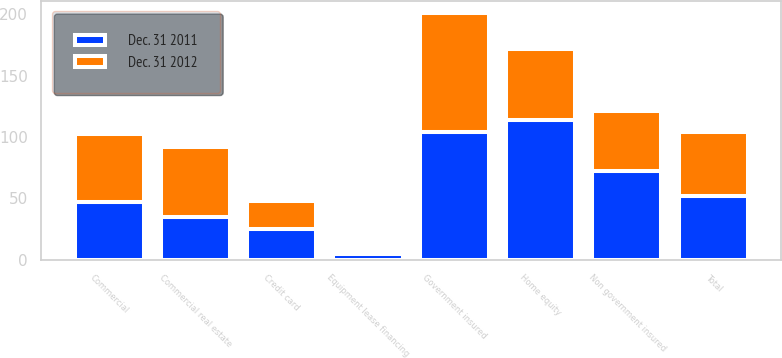Convert chart. <chart><loc_0><loc_0><loc_500><loc_500><stacked_bar_chart><ecel><fcel>Commercial<fcel>Commercial real estate<fcel>Equipment lease financing<fcel>Home equity<fcel>Non government insured<fcel>Government insured<fcel>Credit card<fcel>Total<nl><fcel>Dec. 31 2012<fcel>55<fcel>57<fcel>1<fcel>58<fcel>49<fcel>97<fcel>23<fcel>52<nl><fcel>Dec. 31 2011<fcel>47<fcel>35<fcel>5<fcel>114<fcel>72<fcel>104<fcel>25<fcel>52<nl></chart> 